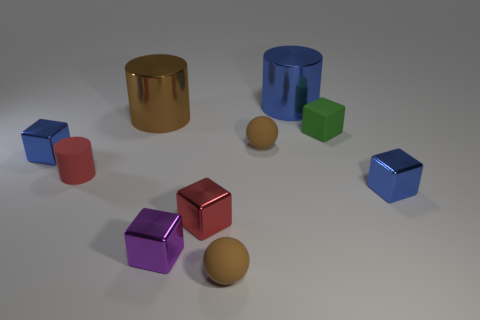Subtract all cylinders. How many objects are left? 7 Subtract all tiny rubber cubes. Subtract all small blue metallic things. How many objects are left? 7 Add 5 brown objects. How many brown objects are left? 8 Add 2 tiny blue metal objects. How many tiny blue metal objects exist? 4 Subtract all red cylinders. How many cylinders are left? 2 Subtract all metal cylinders. How many cylinders are left? 1 Subtract 0 brown blocks. How many objects are left? 10 Subtract 3 cylinders. How many cylinders are left? 0 Subtract all brown cubes. Subtract all brown spheres. How many cubes are left? 5 Subtract all red cylinders. How many red blocks are left? 1 